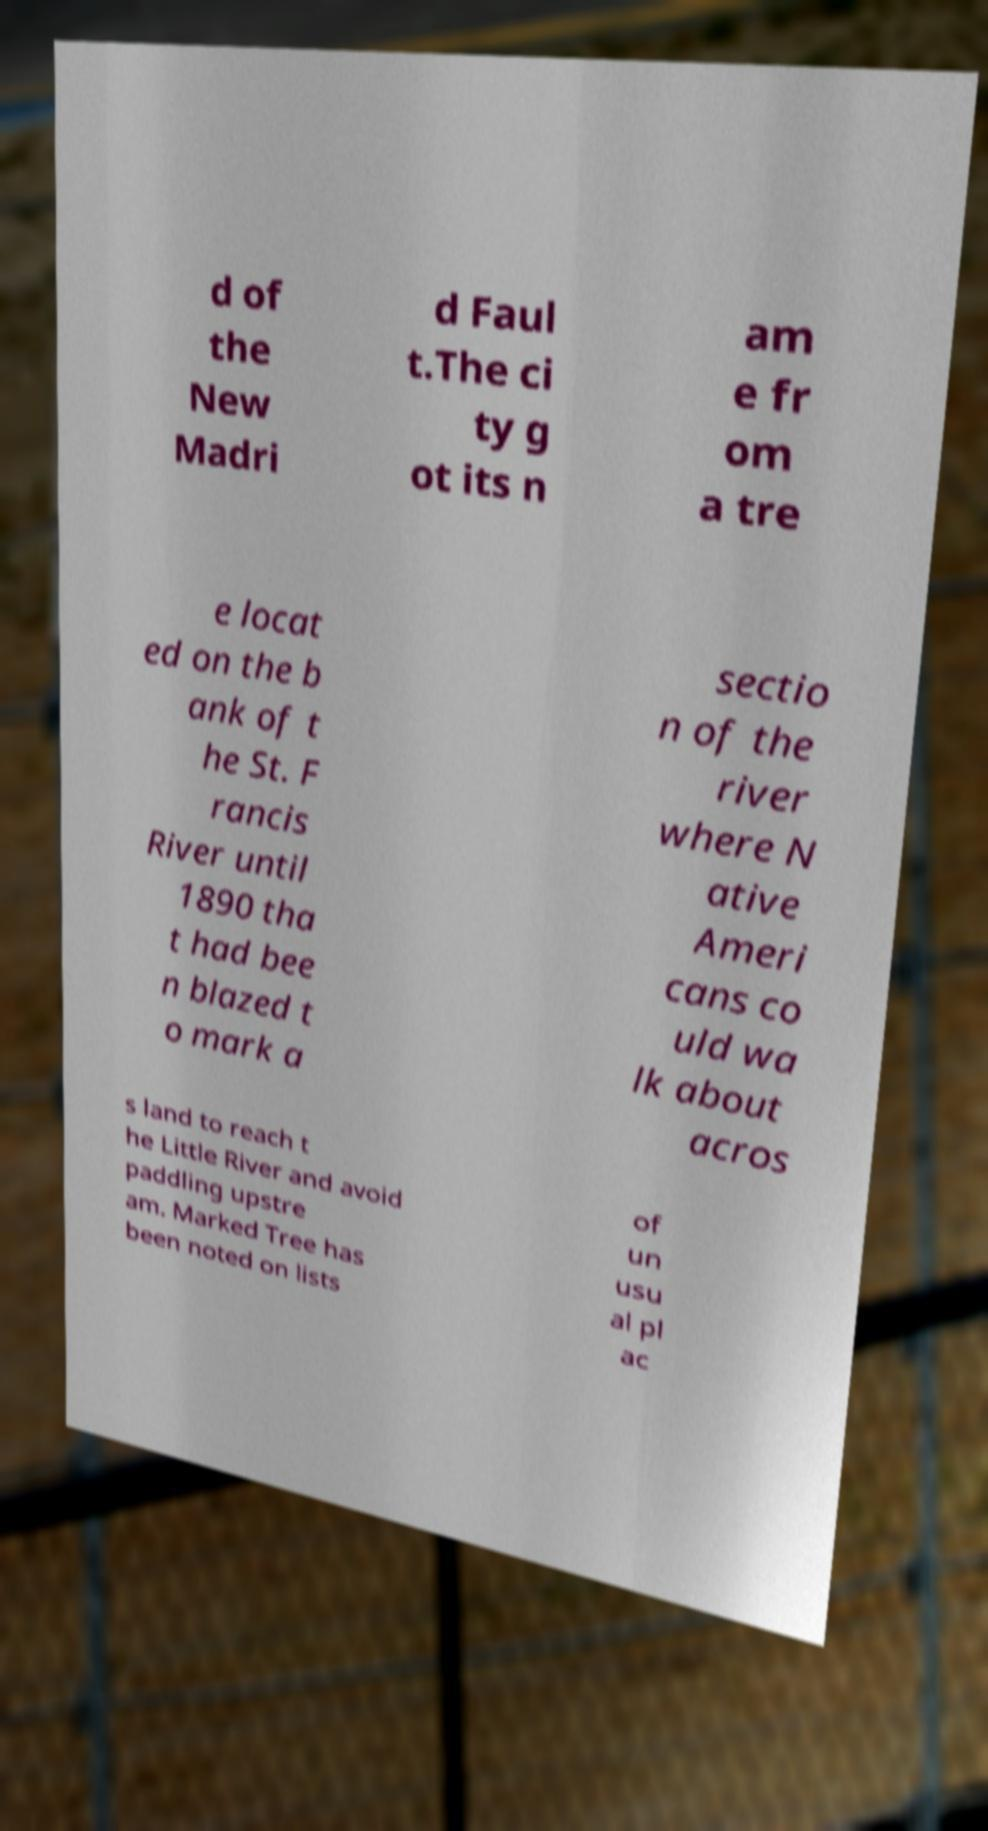Could you extract and type out the text from this image? d of the New Madri d Faul t.The ci ty g ot its n am e fr om a tre e locat ed on the b ank of t he St. F rancis River until 1890 tha t had bee n blazed t o mark a sectio n of the river where N ative Ameri cans co uld wa lk about acros s land to reach t he Little River and avoid paddling upstre am. Marked Tree has been noted on lists of un usu al pl ac 